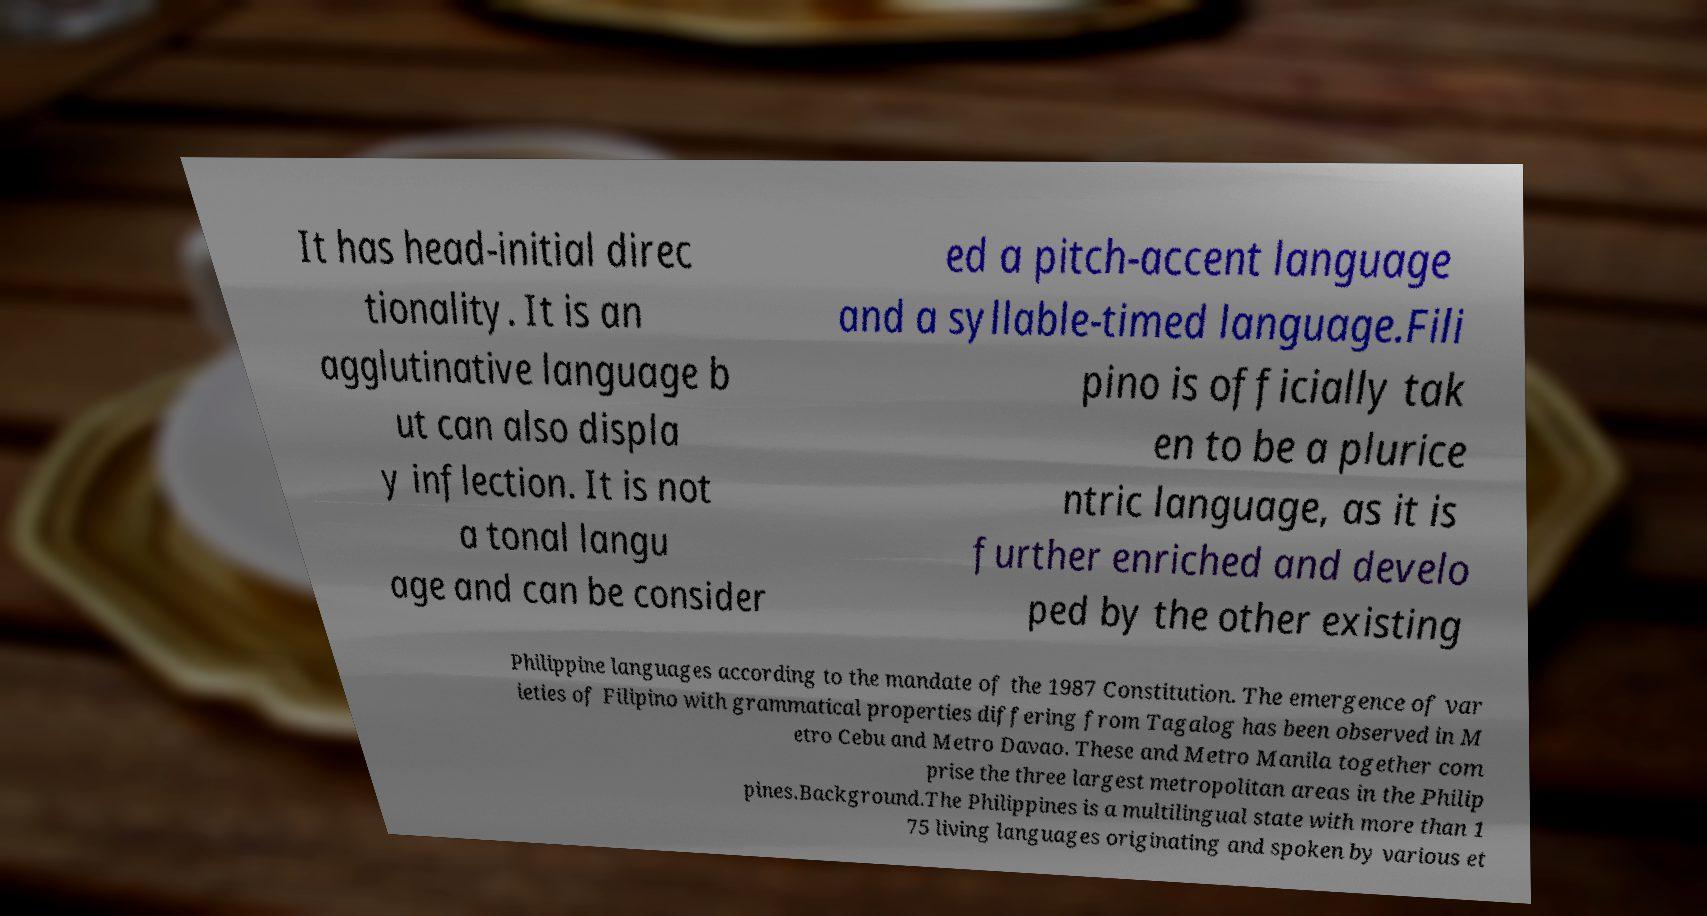Could you assist in decoding the text presented in this image and type it out clearly? It has head-initial direc tionality. It is an agglutinative language b ut can also displa y inflection. It is not a tonal langu age and can be consider ed a pitch-accent language and a syllable-timed language.Fili pino is officially tak en to be a plurice ntric language, as it is further enriched and develo ped by the other existing Philippine languages according to the mandate of the 1987 Constitution. The emergence of var ieties of Filipino with grammatical properties differing from Tagalog has been observed in M etro Cebu and Metro Davao. These and Metro Manila together com prise the three largest metropolitan areas in the Philip pines.Background.The Philippines is a multilingual state with more than 1 75 living languages originating and spoken by various et 